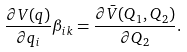Convert formula to latex. <formula><loc_0><loc_0><loc_500><loc_500>\frac { \partial V ( q ) } { \partial q _ { i } } \beta _ { i k } = \frac { \partial \bar { V } ( Q _ { 1 } , Q _ { 2 } ) } { \partial Q _ { 2 } } .</formula> 